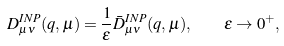Convert formula to latex. <formula><loc_0><loc_0><loc_500><loc_500>D _ { \mu \nu } ^ { I N P } ( q , \mu ) = { \frac { 1 } { \epsilon } } \bar { D } _ { \mu \nu } ^ { I N P } ( q , \mu ) , \quad \epsilon \rightarrow 0 ^ { + } ,</formula> 